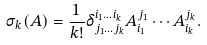<formula> <loc_0><loc_0><loc_500><loc_500>\sigma _ { k } ( A ) = \frac { 1 } { k ! } \delta ^ { i _ { 1 } \dots i _ { k } } _ { j _ { 1 } \dots j _ { k } } A _ { i _ { 1 } } ^ { j _ { 1 } } \cdots A _ { i _ { k } } ^ { j _ { k } } .</formula> 